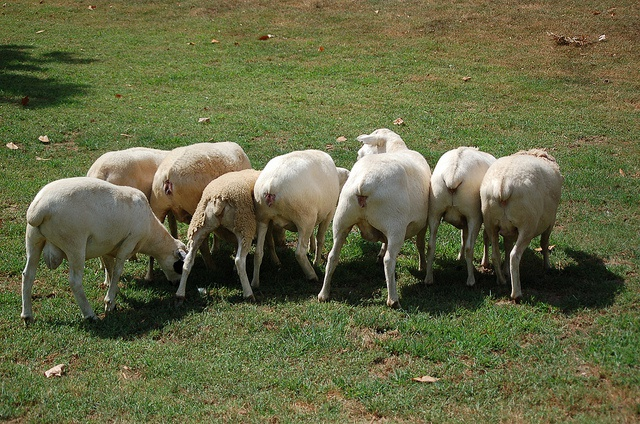Describe the objects in this image and their specific colors. I can see sheep in olive, gray, darkgreen, black, and lightgray tones, sheep in olive, gray, ivory, darkgray, and black tones, sheep in olive, darkgreen, gray, black, and lightgray tones, sheep in olive, darkgray, ivory, and gray tones, and sheep in olive, lightgray, black, darkgreen, and gray tones in this image. 